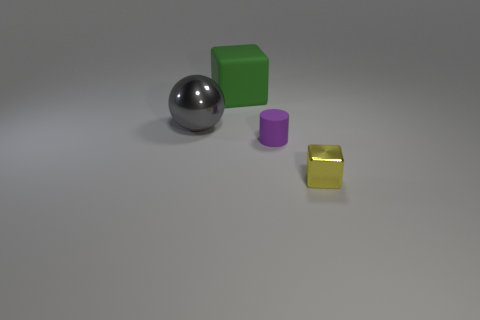Does the gray object have the same shape as the small purple thing?
Your response must be concise. No. How many other things are there of the same shape as the purple thing?
Offer a terse response. 0. What is the color of the metallic object that is the same size as the green rubber object?
Your response must be concise. Gray. Is the number of tiny metal things that are behind the large green cube the same as the number of small brown cylinders?
Your answer should be very brief. Yes. What shape is the thing that is both behind the yellow block and in front of the big gray metal ball?
Offer a very short reply. Cylinder. Do the ball and the green matte block have the same size?
Your answer should be very brief. Yes. Are there any big green objects made of the same material as the big green block?
Keep it short and to the point. No. What number of big things are both behind the big gray sphere and in front of the large green block?
Provide a short and direct response. 0. There is a large thing that is behind the gray object; what material is it?
Provide a succinct answer. Rubber. There is a block that is the same material as the big gray thing; what size is it?
Provide a succinct answer. Small. 